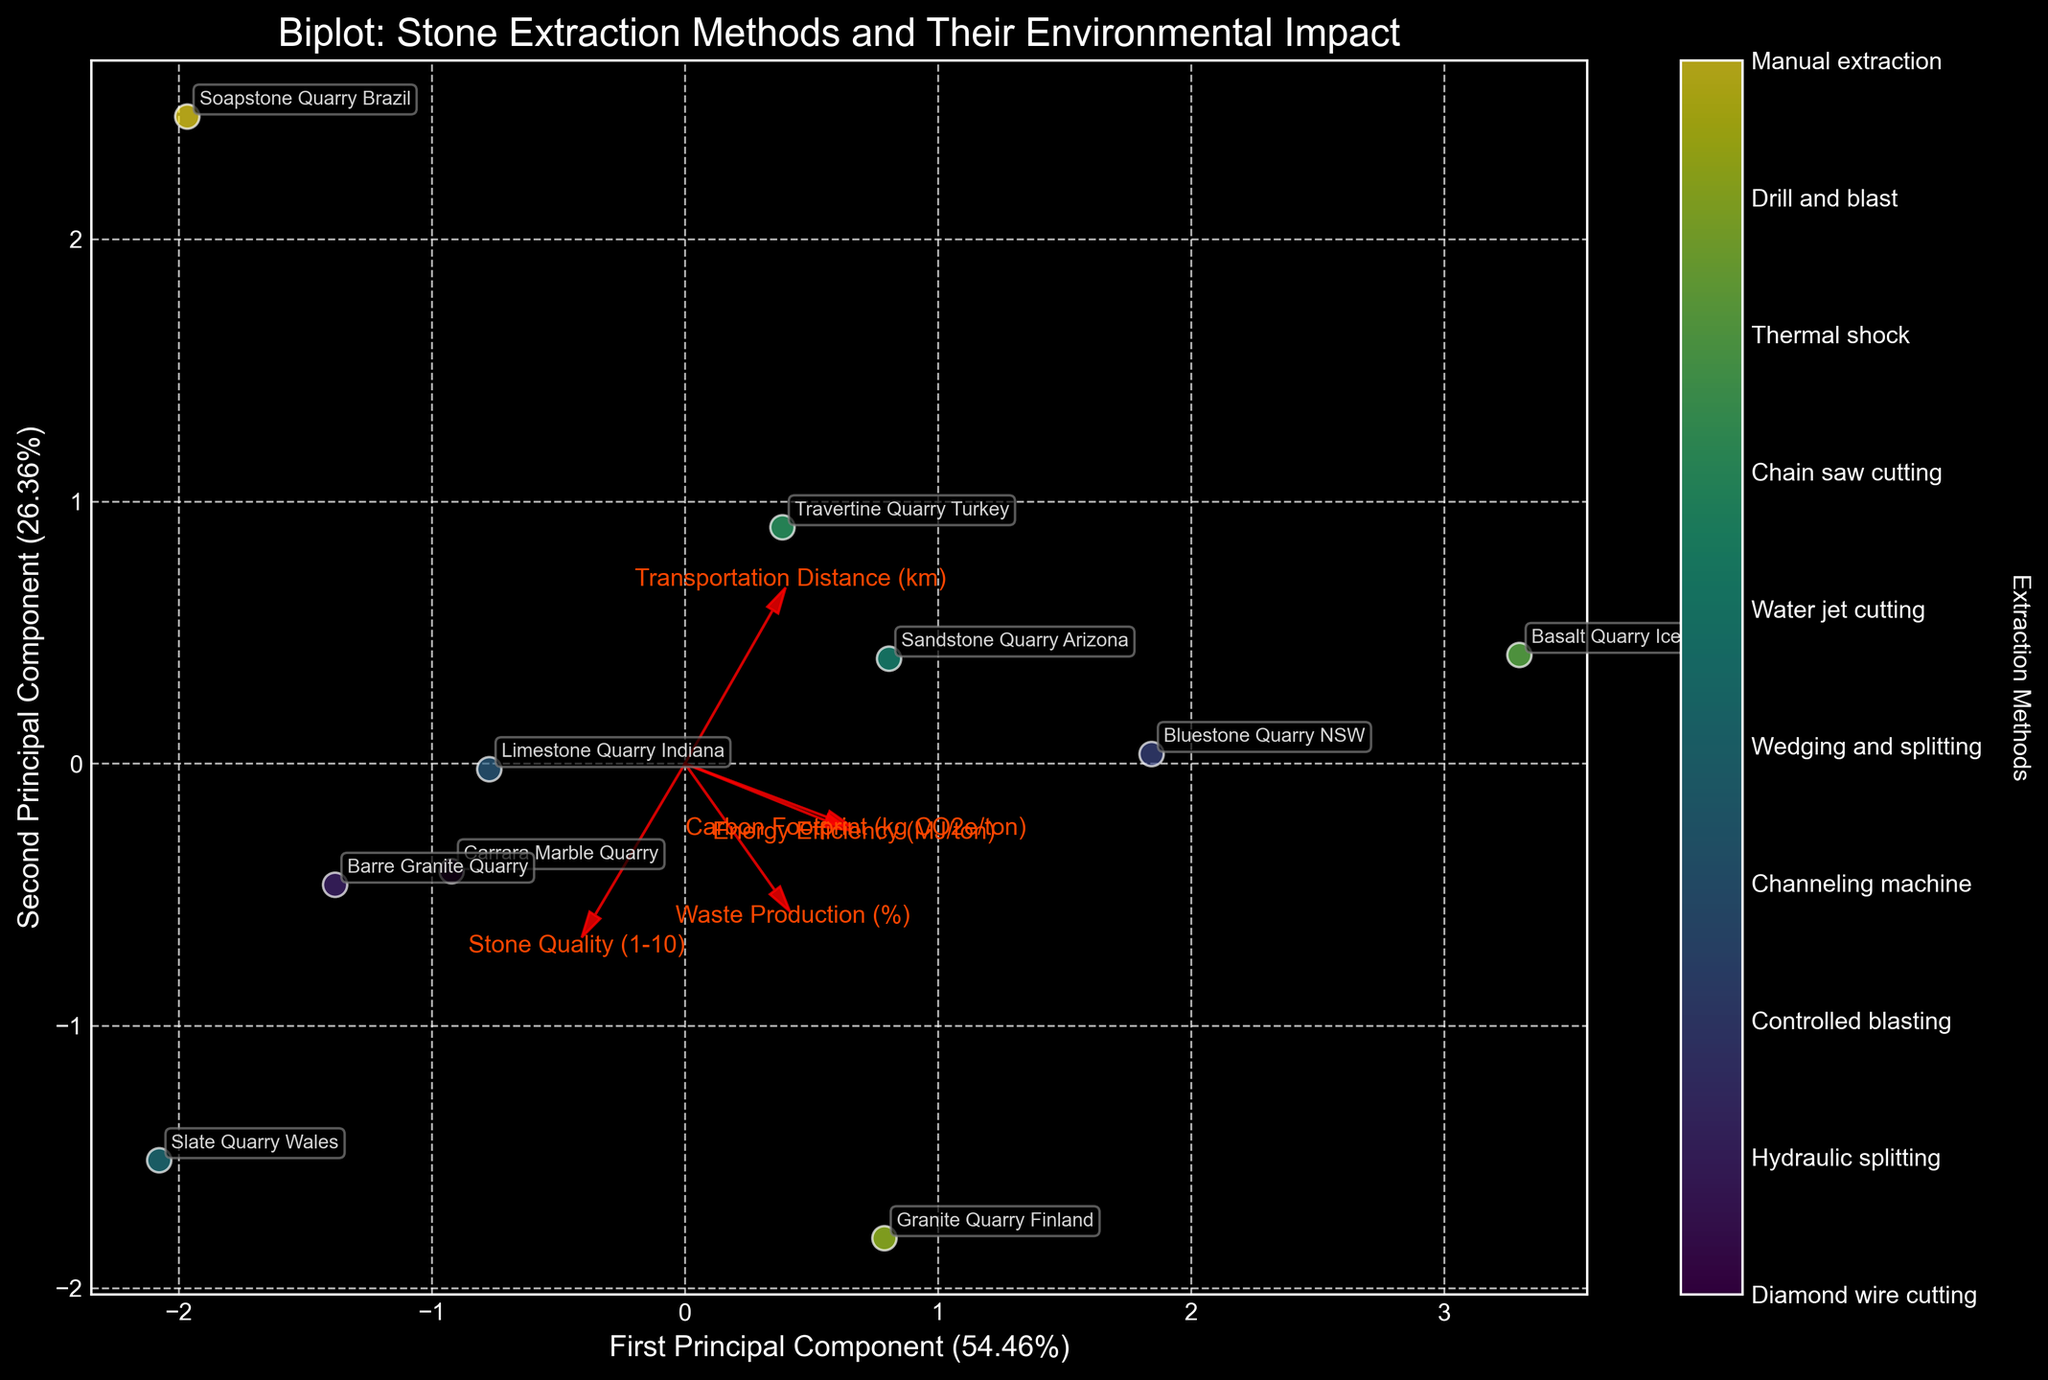What is the title of the plot? The title is displayed at the top of the biplot, indicating the main focus of the figure.
Answer: Biplot: Stone Extraction Methods and Their Environmental Impact How many extraction methods are represented in this biplot? By looking at the color bar and the unique points in the scatter plot, you can count how many different labels there are.
Answer: 10 Which quarry has the highest carbon footprint, based on the biplot? The quarry positioned furthest in the direction of the "Carbon Footprint" vector indicates the highest carbon footprint.
Answer: Bluestone Quarry NSW Which quarry is associated with manual extraction? Find the specific point annotated with the quarry name "Soapstone Quarry Brazil" to identify the manual extraction method.
Answer: Soapstone Quarry Brazil Which principal component explains more variance in the dataset? By observing the axis labels, you can compare the percentages of explained variance. The component with the higher percentage explains more variance.
Answer: First Principal Component Which feature vector is the least aligned with the two principal components? Observing the biplot shows the direction and length of the feature vectors, where the smallest segment indicates the least alignment.
Answer: Waste Production (%) Which quarries are indicated as having the highest stone quality? On the biplot, the quarries furthest in the direction of the "Stone Quality" vector should have the highest stone quality.
Answer: Carrara Marble Quarry, Granite Quarry Finland, Slate Quarry Wales How do the carbon footprint and energy efficiency relate in this biplot? Comparing the directions and proximities of the 'Carbon Footprint' and 'Energy Efficiency' vectors tells the relationship. Closer or similar directions indicate a positive correlation.
Answer: Positive correlation Are quarries with higher transportation distances generally better or worse in waste production? Look at the directions and lengths of the 'Transportation Distance' and 'Waste Production' vectors. If they point in similar directions, it suggests a positive relationship, meaning higher transportation distances are associated with higher waste production.
Answer: Higher transportation distances are associated with higher waste production Which quarry is most energy-efficient and how can you tell? The quarry furthest in the negative direction of the "Energy Efficiency" vector should be the most energy-efficient.
Answer: Soapstone Quarry Brazil 